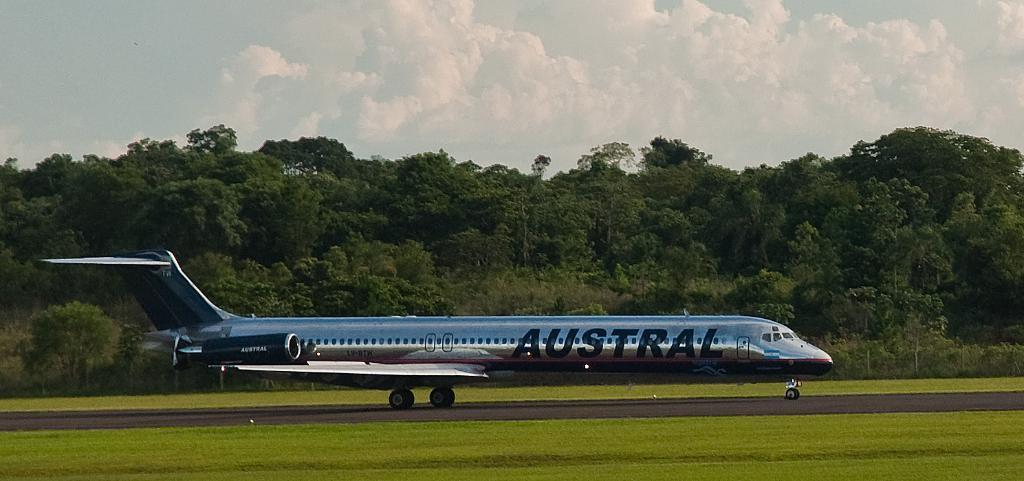<image>
Create a compact narrative representing the image presented. a silver airplane sitting on a runway with the austral logo on it. 